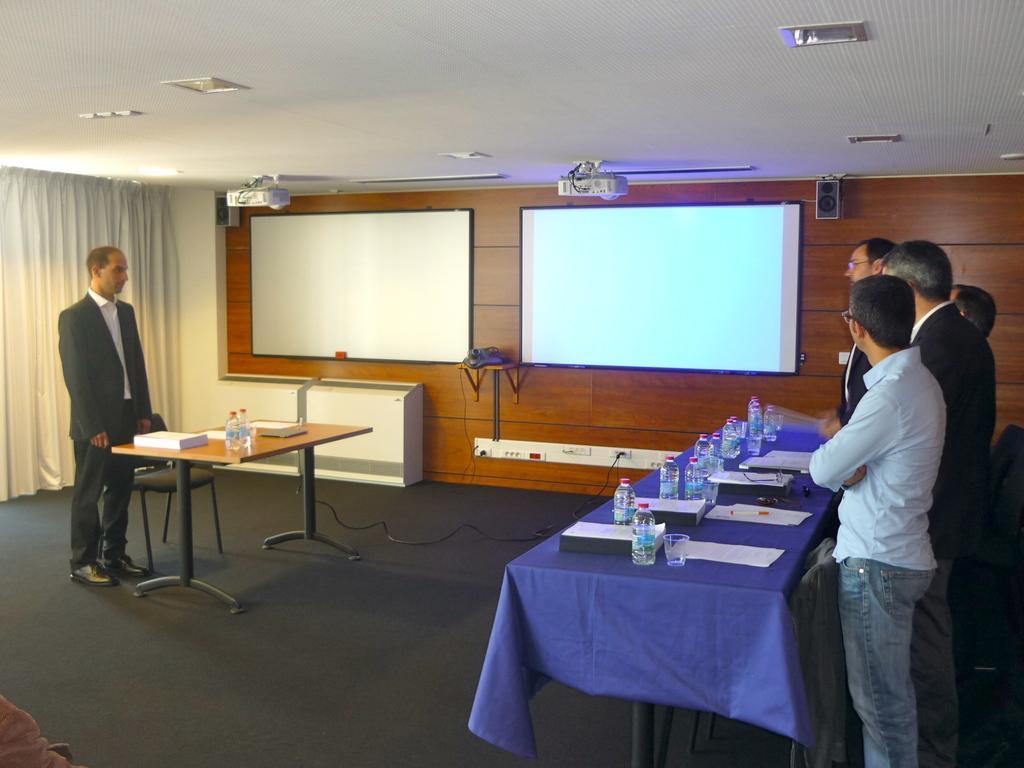Please provide a concise description of this image. This is a picture taken in a seminar hall, there are a group of people standing on the floor. The floor is in black color. On the floor there is a table, the table is covered with a blue cloth on the table there is a paper, glass, bottle and a laptop. Background of this people there is a screens. On top of this people there is a roof with two projectors and a lights. 